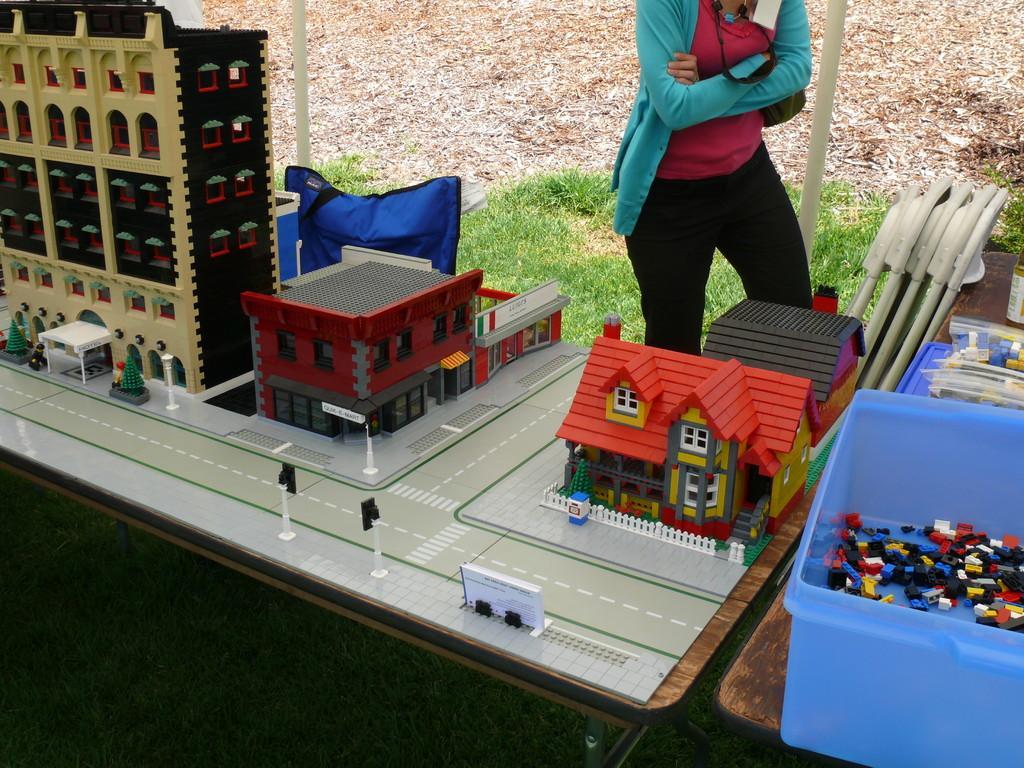Can you describe this image briefly? In this image I can see miniature buildings and poles. We can see a blue color box and something is inside it. We can see some object on the table. Back I can see a person wearing blue coat and pink and black color dress. We can see a green color grass. 